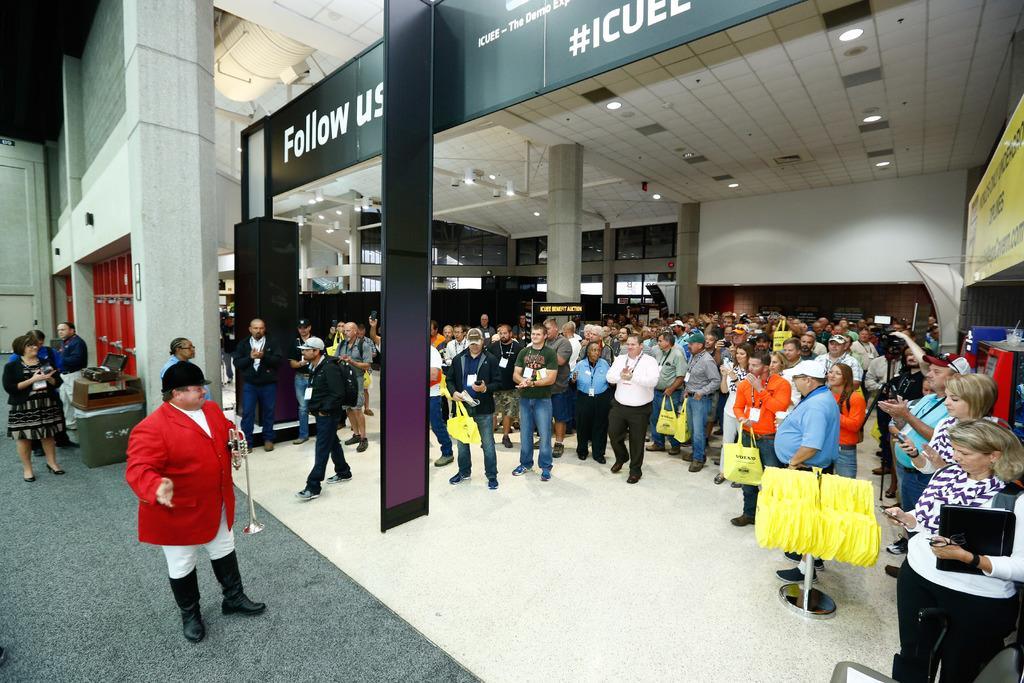Could you give a brief overview of what you see in this image? On the right side of the image there are some group of people standing, some are holding bags in their hands and there is a stand on the floor and some bags are hanging in the stand. On the left side of the image there are a few people standing on the carpet on the floor. At the top of the image there are lights. 